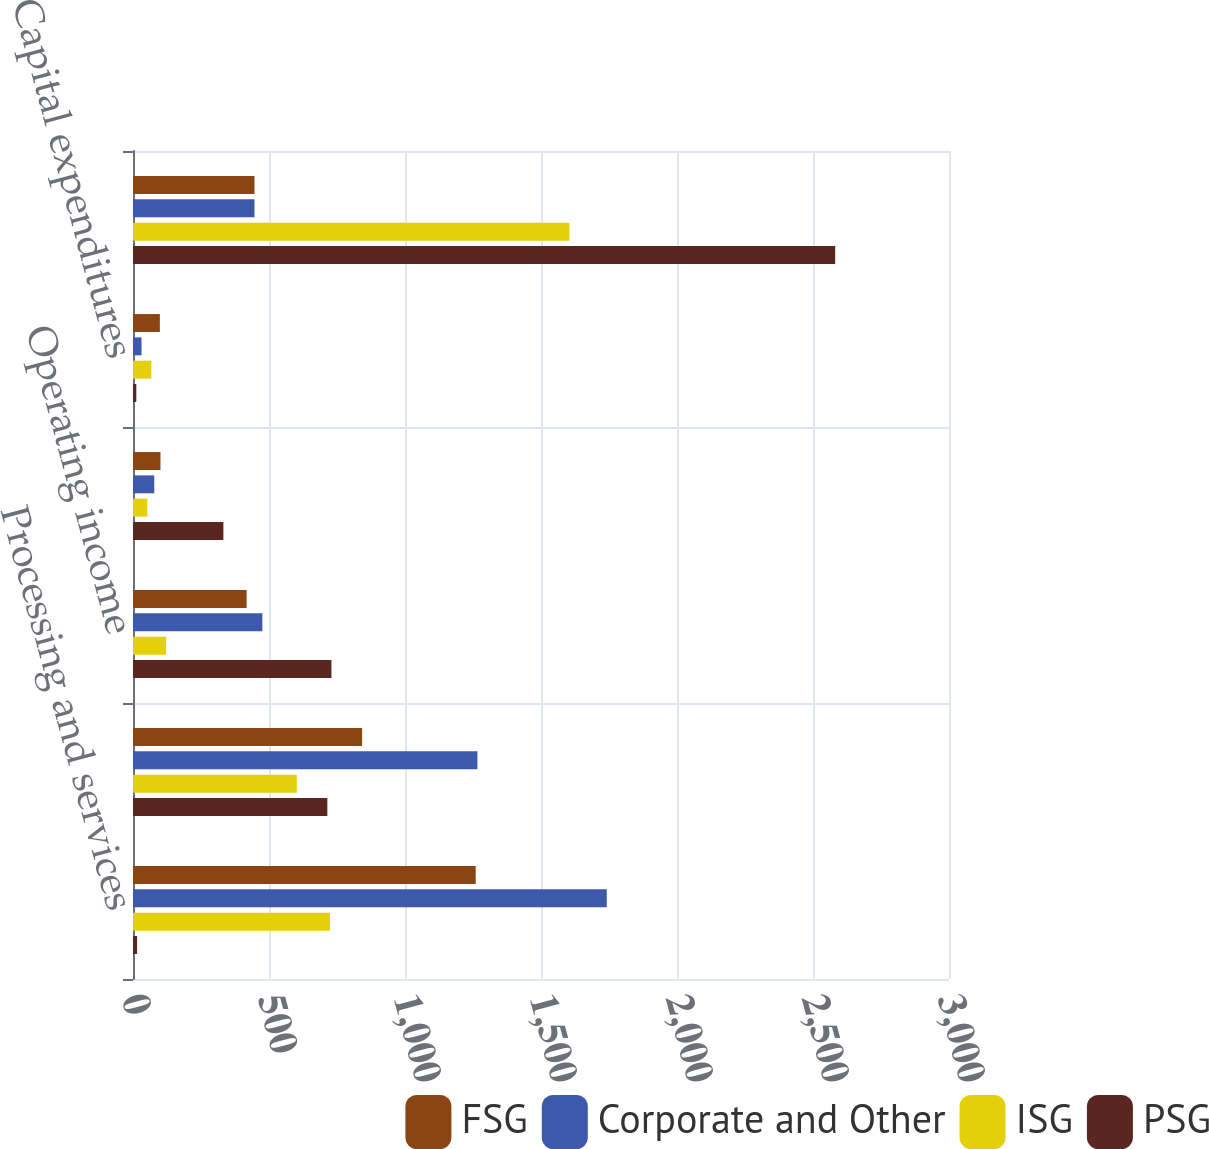Convert chart to OTSL. <chart><loc_0><loc_0><loc_500><loc_500><stacked_bar_chart><ecel><fcel>Processing and services<fcel>Operating expenses<fcel>Operating income<fcel>Depreciation and amortization<fcel>Capital expenditures<fcel>Total assets<nl><fcel>FSG<fcel>1260<fcel>842.3<fcel>417.7<fcel>101<fcel>98.8<fcel>446.65<nl><fcel>Corporate and Other<fcel>1741.9<fcel>1266.3<fcel>475.6<fcel>78.2<fcel>31.3<fcel>446.65<nl><fcel>ISG<fcel>724.3<fcel>602.4<fcel>121.9<fcel>52.9<fcel>67.4<fcel>1604.5<nl><fcel>PSG<fcel>15.1<fcel>714.5<fcel>729.6<fcel>332.3<fcel>12.1<fcel>2581.5<nl></chart> 